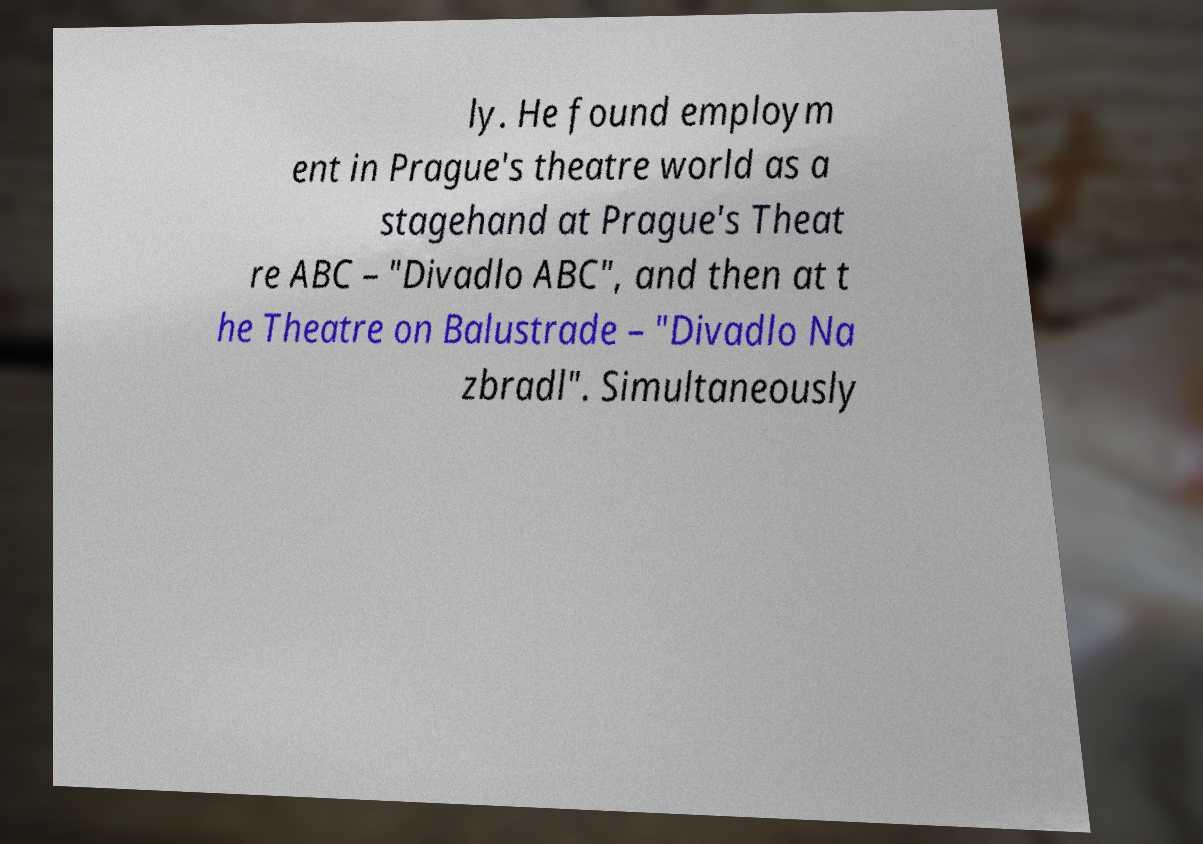I need the written content from this picture converted into text. Can you do that? ly. He found employm ent in Prague's theatre world as a stagehand at Prague's Theat re ABC – "Divadlo ABC", and then at t he Theatre on Balustrade – "Divadlo Na zbradl". Simultaneously 